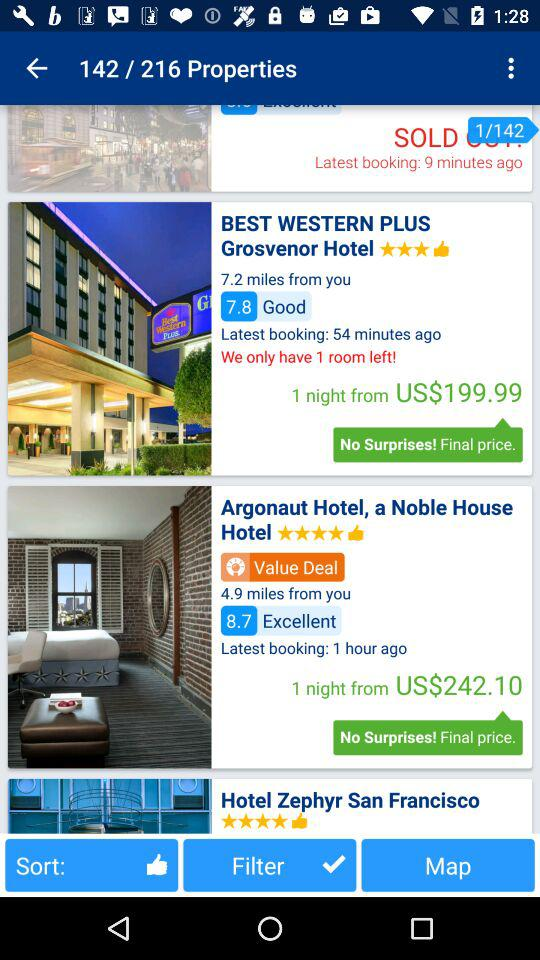How far is the Best Western Plus Grosvenor Hotel? The "Best Western Plus Grosvenor Hotel" is 7.2 miles away. 